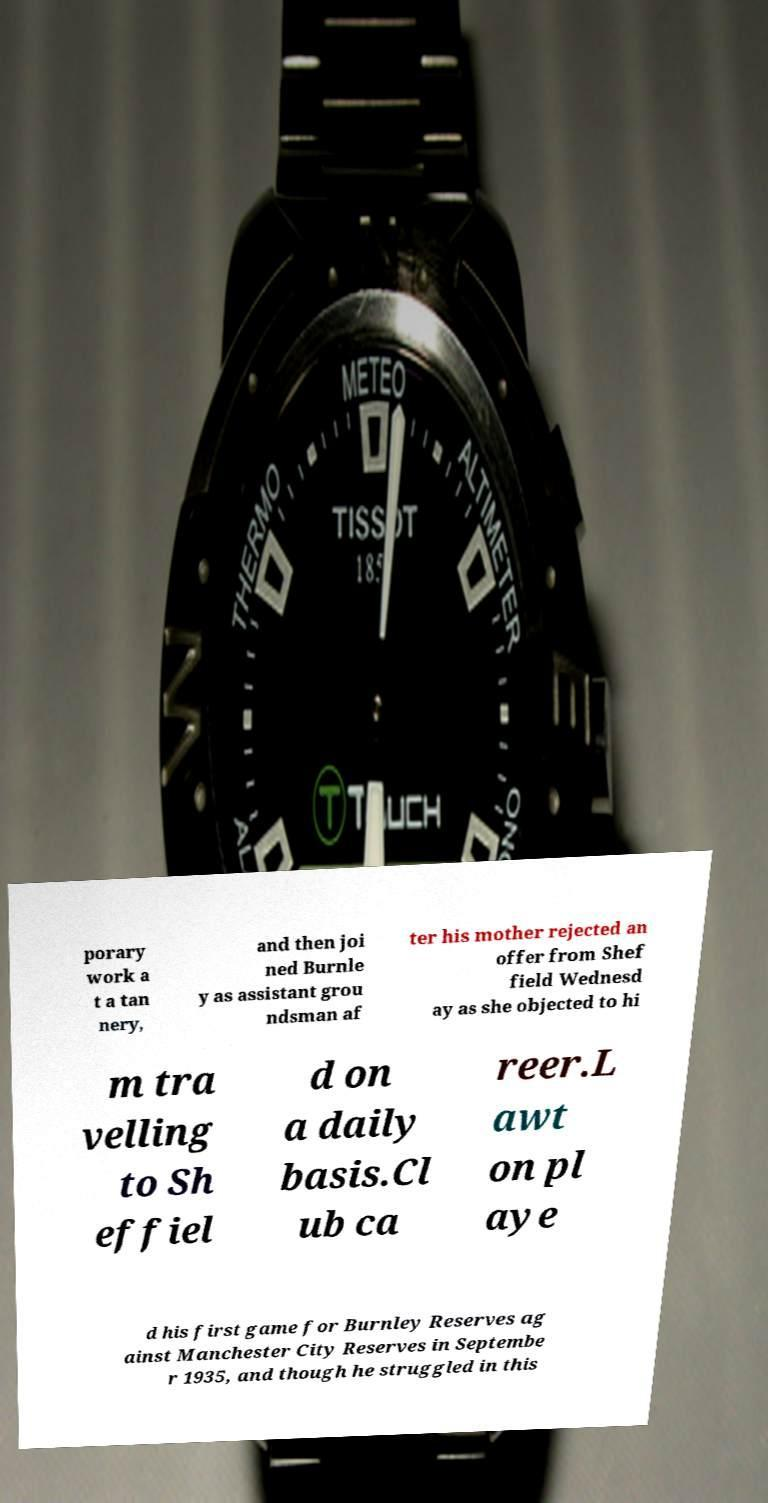Can you read and provide the text displayed in the image?This photo seems to have some interesting text. Can you extract and type it out for me? porary work a t a tan nery, and then joi ned Burnle y as assistant grou ndsman af ter his mother rejected an offer from Shef field Wednesd ay as she objected to hi m tra velling to Sh effiel d on a daily basis.Cl ub ca reer.L awt on pl aye d his first game for Burnley Reserves ag ainst Manchester City Reserves in Septembe r 1935, and though he struggled in this 